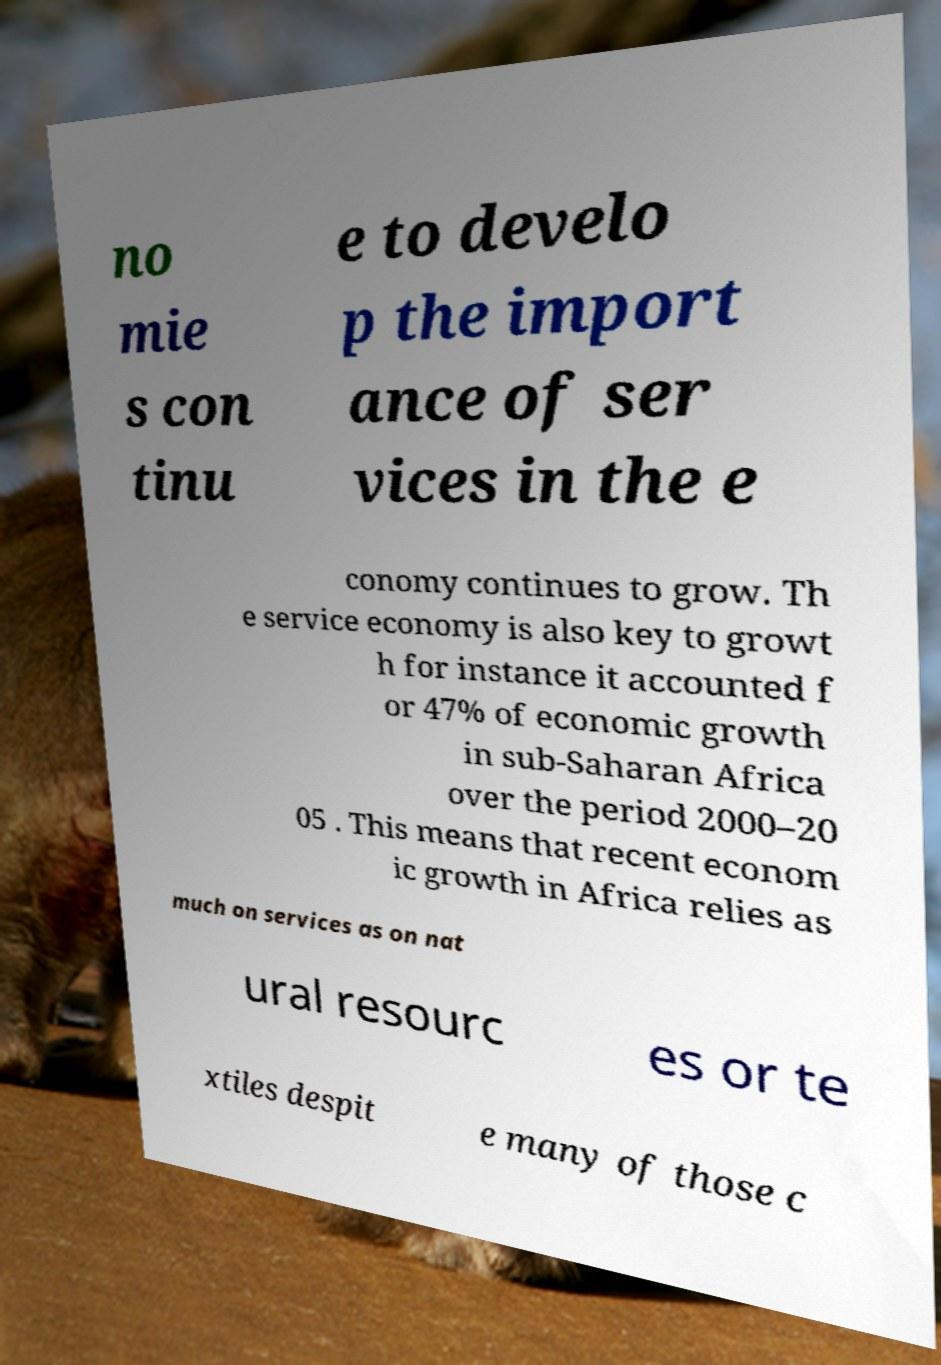Can you accurately transcribe the text from the provided image for me? no mie s con tinu e to develo p the import ance of ser vices in the e conomy continues to grow. Th e service economy is also key to growt h for instance it accounted f or 47% of economic growth in sub-Saharan Africa over the period 2000–20 05 . This means that recent econom ic growth in Africa relies as much on services as on nat ural resourc es or te xtiles despit e many of those c 